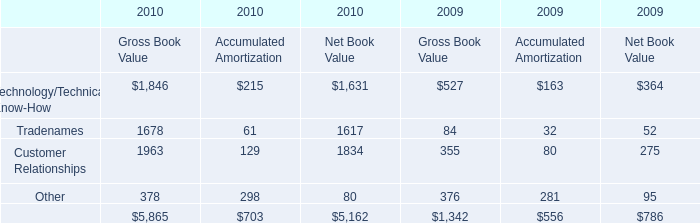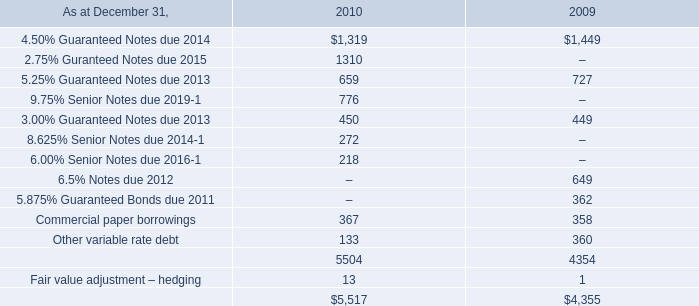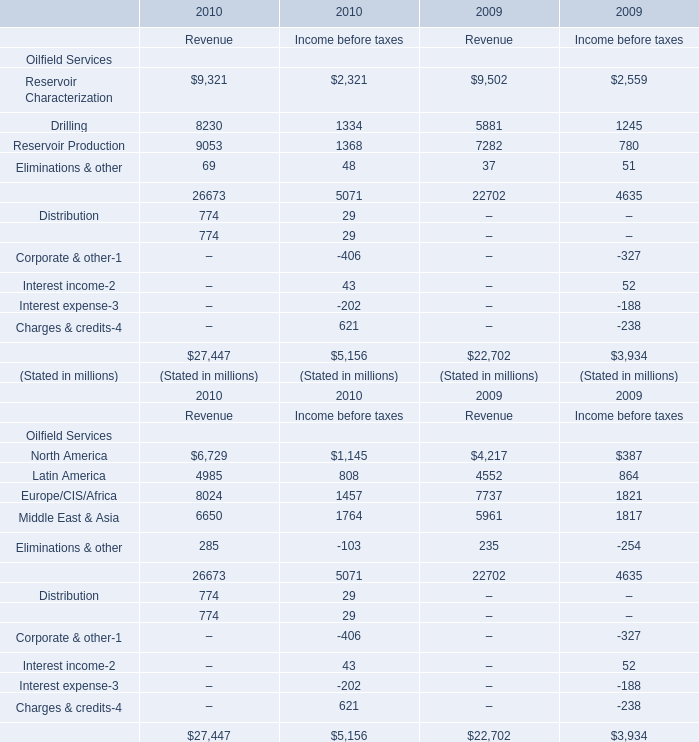What is the average amount of Tradenames of 2010 Gross Book Value, and Drilling of 2009 Income before taxes ? 
Computations: ((1678.0 + 1245.0) / 2)
Answer: 1461.5. 